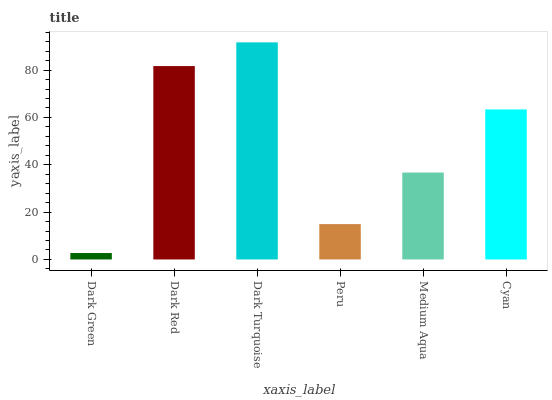Is Dark Green the minimum?
Answer yes or no. Yes. Is Dark Turquoise the maximum?
Answer yes or no. Yes. Is Dark Red the minimum?
Answer yes or no. No. Is Dark Red the maximum?
Answer yes or no. No. Is Dark Red greater than Dark Green?
Answer yes or no. Yes. Is Dark Green less than Dark Red?
Answer yes or no. Yes. Is Dark Green greater than Dark Red?
Answer yes or no. No. Is Dark Red less than Dark Green?
Answer yes or no. No. Is Cyan the high median?
Answer yes or no. Yes. Is Medium Aqua the low median?
Answer yes or no. Yes. Is Dark Green the high median?
Answer yes or no. No. Is Dark Red the low median?
Answer yes or no. No. 